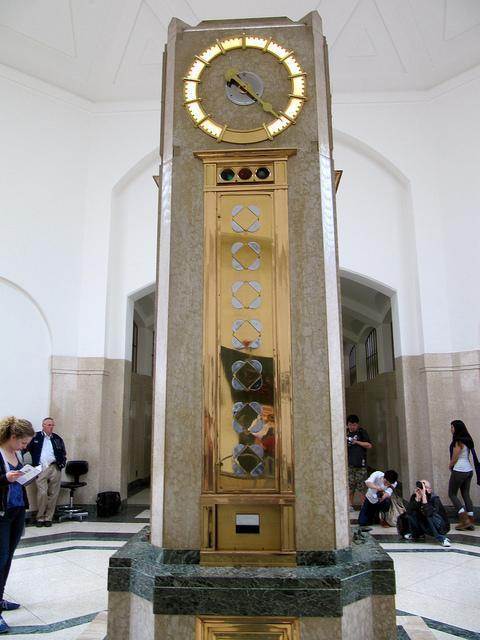The hand of the clock is closest to what number?
Make your selection from the four choices given to correctly answer the question.
Options: Twelve, nine, five, one. Five. 